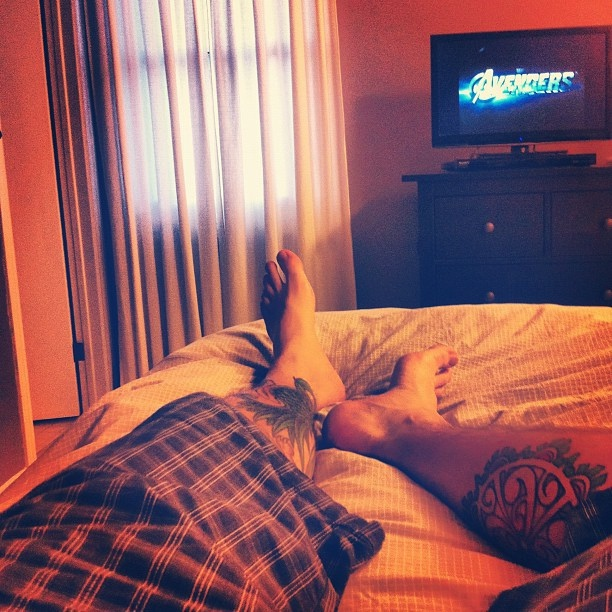Describe the objects in this image and their specific colors. I can see people in brown, purple, black, and salmon tones and tv in brown, navy, purple, black, and beige tones in this image. 